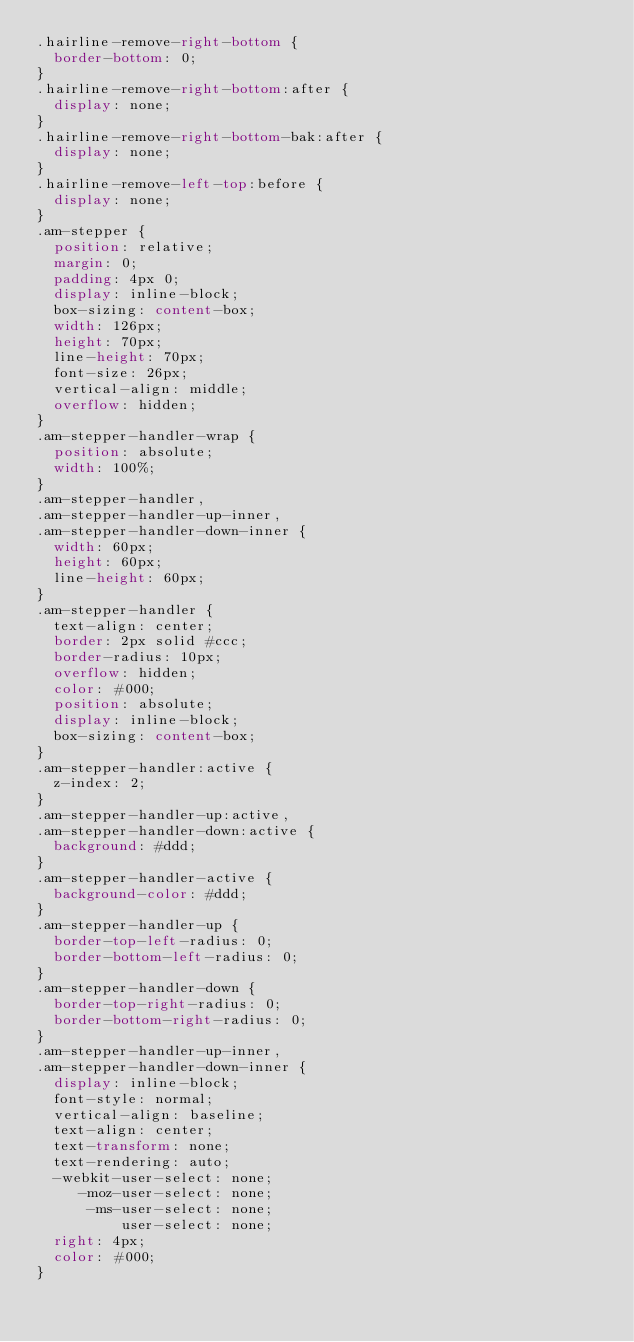Convert code to text. <code><loc_0><loc_0><loc_500><loc_500><_CSS_>.hairline-remove-right-bottom {
  border-bottom: 0;
}
.hairline-remove-right-bottom:after {
  display: none;
}
.hairline-remove-right-bottom-bak:after {
  display: none;
}
.hairline-remove-left-top:before {
  display: none;
}
.am-stepper {
  position: relative;
  margin: 0;
  padding: 4px 0;
  display: inline-block;
  box-sizing: content-box;
  width: 126px;
  height: 70px;
  line-height: 70px;
  font-size: 26px;
  vertical-align: middle;
  overflow: hidden;
}
.am-stepper-handler-wrap {
  position: absolute;
  width: 100%;
}
.am-stepper-handler,
.am-stepper-handler-up-inner,
.am-stepper-handler-down-inner {
  width: 60px;
  height: 60px;
  line-height: 60px;
}
.am-stepper-handler {
  text-align: center;
  border: 2px solid #ccc;
  border-radius: 10px;
  overflow: hidden;
  color: #000;
  position: absolute;
  display: inline-block;
  box-sizing: content-box;
}
.am-stepper-handler:active {
  z-index: 2;
}
.am-stepper-handler-up:active,
.am-stepper-handler-down:active {
  background: #ddd;
}
.am-stepper-handler-active {
  background-color: #ddd;
}
.am-stepper-handler-up {
  border-top-left-radius: 0;
  border-bottom-left-radius: 0;
}
.am-stepper-handler-down {
  border-top-right-radius: 0;
  border-bottom-right-radius: 0;
}
.am-stepper-handler-up-inner,
.am-stepper-handler-down-inner {
  display: inline-block;
  font-style: normal;
  vertical-align: baseline;
  text-align: center;
  text-transform: none;
  text-rendering: auto;
  -webkit-user-select: none;
     -moz-user-select: none;
      -ms-user-select: none;
          user-select: none;
  right: 4px;
  color: #000;
}</code> 